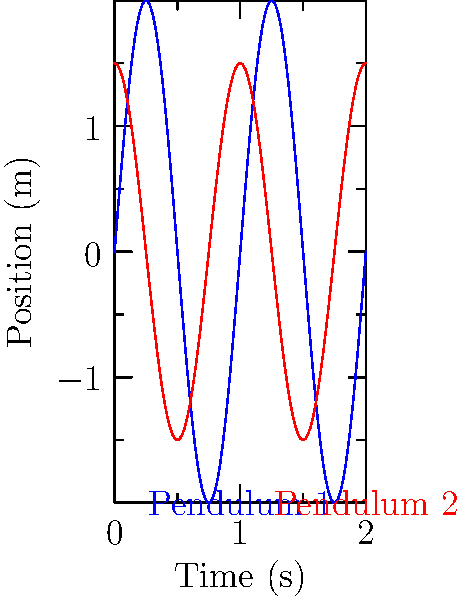Given the position-time graphs for two coupled pendulums in a harmonic oscillator system, determine the phase difference between the oscillations. Assume both pendulums have the same frequency. How does this phase difference relate to the energy transfer between the pendulums? To solve this problem, we'll follow these steps:

1) First, we need to identify the phase difference between the two oscillations. In harmonic motion, phase difference is represented by the time shift between two otherwise identical waves.

2) From the graph, we can see that the blue curve (Pendulum 1) follows a sine function, while the red curve (Pendulum 2) appears to be a cosine function, or a sine function shifted by $\pi/2$.

3) The relationship between sine and cosine is:

   $\cos(x) = \sin(x + \pi/2)$

4) Therefore, the phase difference between the two pendulums is $\pi/2$ radians, or 90°.

5) In terms of energy transfer, this phase difference is significant. In a system of coupled oscillators, energy is continuously exchanged between the two pendulums.

6) When the phase difference is $\pi/2$, it represents a state of maximum energy transfer. This is because when one pendulum is at its maximum displacement (having maximum potential energy), the other is passing through its equilibrium position (having maximum kinetic energy).

7) This $\pi/2$ phase difference leads to a phenomenon called "beats" in coupled oscillators, where the amplitude of each pendulum appears to wax and wane over time as energy is transferred back and forth between them.

8) The frequency of this energy transfer (beat frequency) is related to the coupling strength between the pendulums and their natural frequencies.

Thus, the $\pi/2$ phase difference observed here indicates that the system is in a state of maximum energy transfer between the two pendulums.
Answer: $\pi/2$ radians; maximum energy transfer 